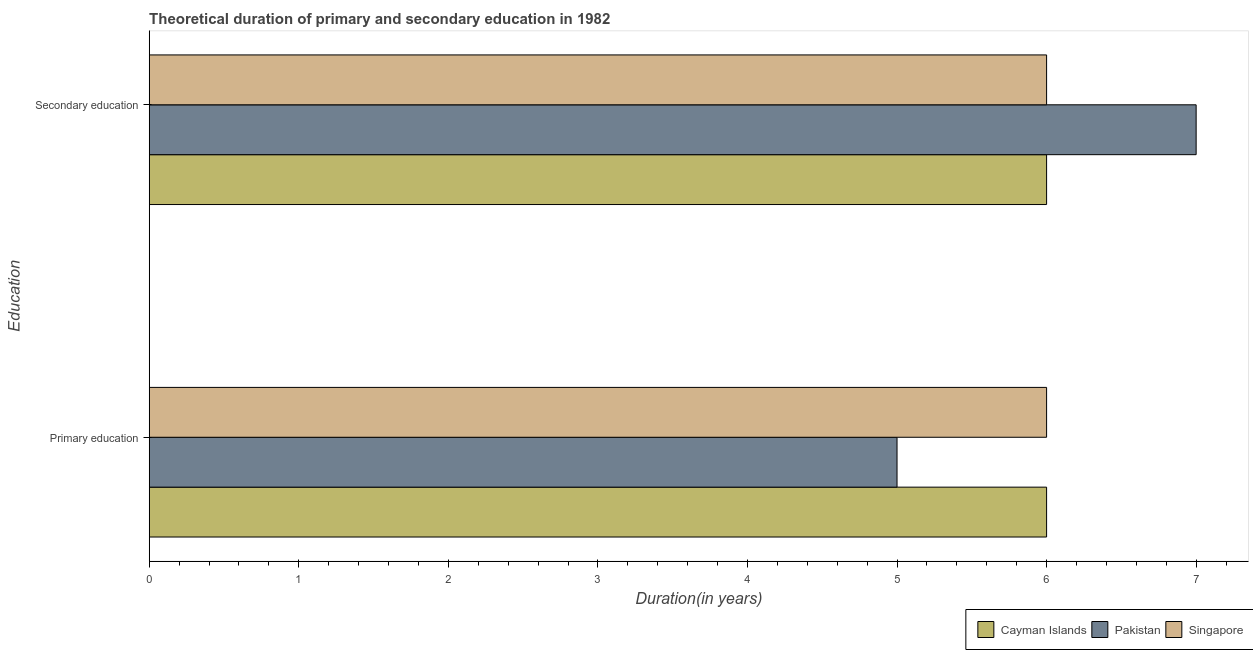How many groups of bars are there?
Make the answer very short. 2. Are the number of bars on each tick of the Y-axis equal?
Ensure brevity in your answer.  Yes. How many bars are there on the 2nd tick from the bottom?
Offer a very short reply. 3. What is the label of the 1st group of bars from the top?
Your answer should be very brief. Secondary education. What is the duration of secondary education in Singapore?
Keep it short and to the point. 6. Across all countries, what is the maximum duration of secondary education?
Make the answer very short. 7. In which country was the duration of primary education minimum?
Your answer should be very brief. Pakistan. What is the total duration of secondary education in the graph?
Make the answer very short. 19. What is the difference between the duration of secondary education in Pakistan and that in Cayman Islands?
Provide a short and direct response. 1. What is the difference between the duration of primary education in Pakistan and the duration of secondary education in Cayman Islands?
Your answer should be compact. -1. What is the average duration of primary education per country?
Provide a short and direct response. 5.67. What is the difference between the duration of secondary education and duration of primary education in Cayman Islands?
Provide a succinct answer. 0. Is the duration of primary education in Singapore less than that in Cayman Islands?
Your answer should be compact. No. In how many countries, is the duration of primary education greater than the average duration of primary education taken over all countries?
Your answer should be very brief. 2. What does the 1st bar from the top in Secondary education represents?
Your answer should be compact. Singapore. What does the 3rd bar from the bottom in Primary education represents?
Provide a succinct answer. Singapore. How many bars are there?
Offer a terse response. 6. Are the values on the major ticks of X-axis written in scientific E-notation?
Provide a succinct answer. No. Does the graph contain grids?
Your answer should be very brief. No. Where does the legend appear in the graph?
Make the answer very short. Bottom right. What is the title of the graph?
Make the answer very short. Theoretical duration of primary and secondary education in 1982. What is the label or title of the X-axis?
Provide a succinct answer. Duration(in years). What is the label or title of the Y-axis?
Provide a succinct answer. Education. What is the Duration(in years) of Cayman Islands in Primary education?
Keep it short and to the point. 6. What is the Duration(in years) in Singapore in Primary education?
Offer a terse response. 6. What is the Duration(in years) of Cayman Islands in Secondary education?
Give a very brief answer. 6. What is the Duration(in years) of Pakistan in Secondary education?
Make the answer very short. 7. Across all Education, what is the maximum Duration(in years) in Cayman Islands?
Your response must be concise. 6. Across all Education, what is the maximum Duration(in years) in Singapore?
Keep it short and to the point. 6. Across all Education, what is the minimum Duration(in years) of Cayman Islands?
Ensure brevity in your answer.  6. What is the difference between the Duration(in years) of Cayman Islands in Primary education and that in Secondary education?
Your answer should be compact. 0. What is the difference between the Duration(in years) in Pakistan in Primary education and that in Secondary education?
Your answer should be compact. -2. What is the difference between the Duration(in years) of Cayman Islands in Primary education and the Duration(in years) of Singapore in Secondary education?
Keep it short and to the point. 0. What is the average Duration(in years) in Singapore per Education?
Offer a very short reply. 6. What is the difference between the Duration(in years) of Cayman Islands and Duration(in years) of Pakistan in Secondary education?
Your answer should be very brief. -1. What is the difference between the Duration(in years) in Cayman Islands and Duration(in years) in Singapore in Secondary education?
Your answer should be very brief. 0. What is the difference between the Duration(in years) in Pakistan and Duration(in years) in Singapore in Secondary education?
Keep it short and to the point. 1. What is the ratio of the Duration(in years) in Cayman Islands in Primary education to that in Secondary education?
Make the answer very short. 1. What is the ratio of the Duration(in years) in Pakistan in Primary education to that in Secondary education?
Your answer should be compact. 0.71. What is the ratio of the Duration(in years) in Singapore in Primary education to that in Secondary education?
Your response must be concise. 1. What is the difference between the highest and the second highest Duration(in years) in Cayman Islands?
Give a very brief answer. 0. What is the difference between the highest and the second highest Duration(in years) in Pakistan?
Give a very brief answer. 2. What is the difference between the highest and the second highest Duration(in years) in Singapore?
Give a very brief answer. 0. What is the difference between the highest and the lowest Duration(in years) of Cayman Islands?
Give a very brief answer. 0. What is the difference between the highest and the lowest Duration(in years) in Pakistan?
Your answer should be compact. 2. 